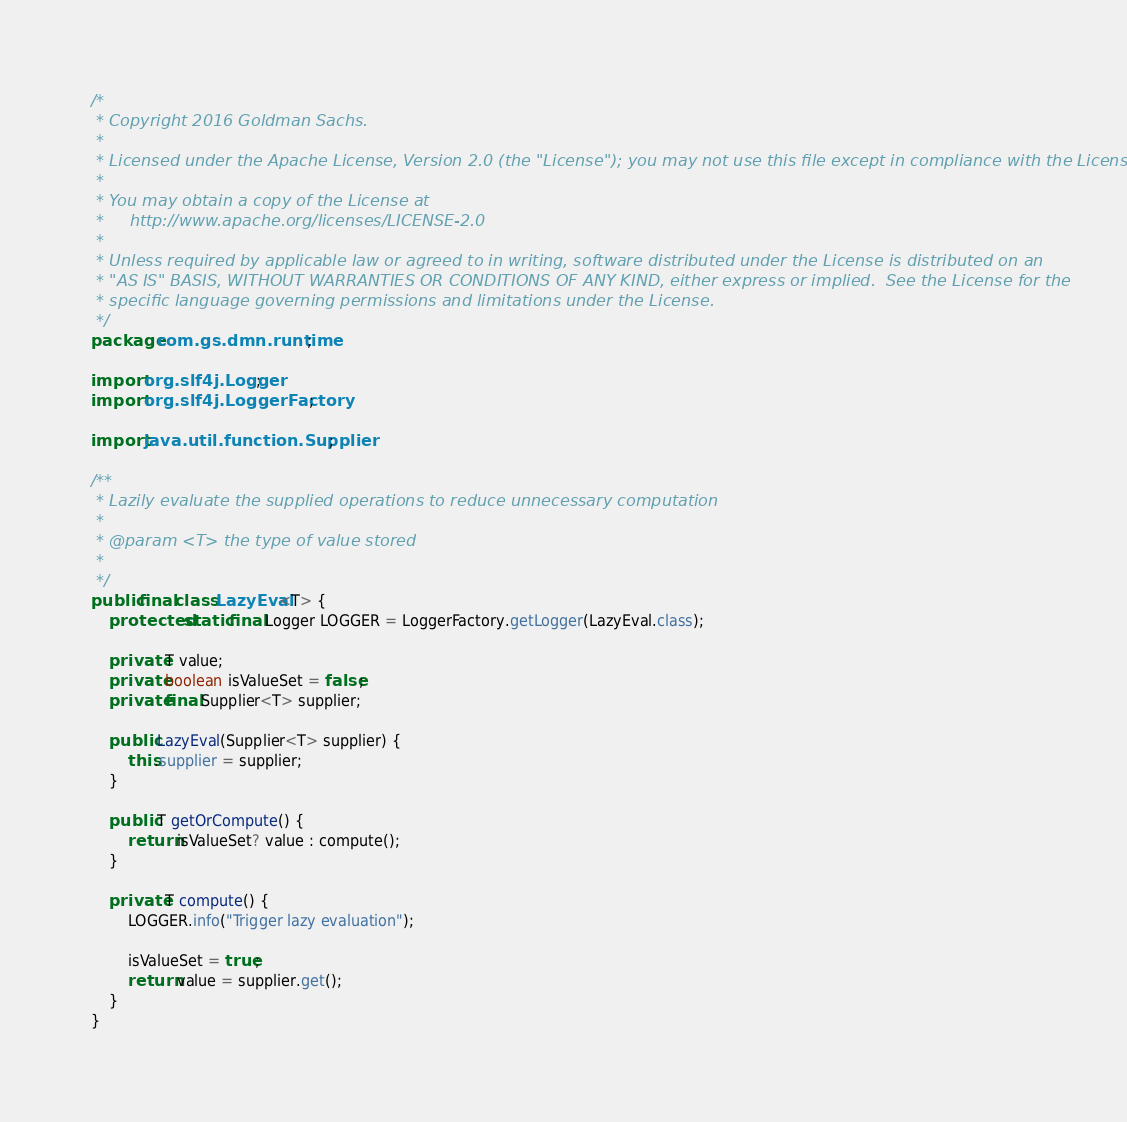Convert code to text. <code><loc_0><loc_0><loc_500><loc_500><_Java_>/*
 * Copyright 2016 Goldman Sachs.
 *
 * Licensed under the Apache License, Version 2.0 (the "License"); you may not use this file except in compliance with the License.
 *
 * You may obtain a copy of the License at
 *     http://www.apache.org/licenses/LICENSE-2.0
 *
 * Unless required by applicable law or agreed to in writing, software distributed under the License is distributed on an
 * "AS IS" BASIS, WITHOUT WARRANTIES OR CONDITIONS OF ANY KIND, either express or implied.  See the License for the
 * specific language governing permissions and limitations under the License.
 */
package com.gs.dmn.runtime;

import org.slf4j.Logger;
import org.slf4j.LoggerFactory;

import java.util.function.Supplier;

/**
 * Lazily evaluate the supplied operations to reduce unnecessary computation
 *
 * @param <T> the type of value stored
 *
 */
public final class LazyEval<T> {
    protected static final Logger LOGGER = LoggerFactory.getLogger(LazyEval.class);

    private T value;
    private boolean isValueSet = false;
    private final Supplier<T> supplier;

    public LazyEval(Supplier<T> supplier) {
        this.supplier = supplier;
    }

    public T getOrCompute() {
        return isValueSet? value : compute();
    }

    private T compute() {
        LOGGER.info("Trigger lazy evaluation");

        isValueSet = true;
        return value = supplier.get();
    }
}</code> 